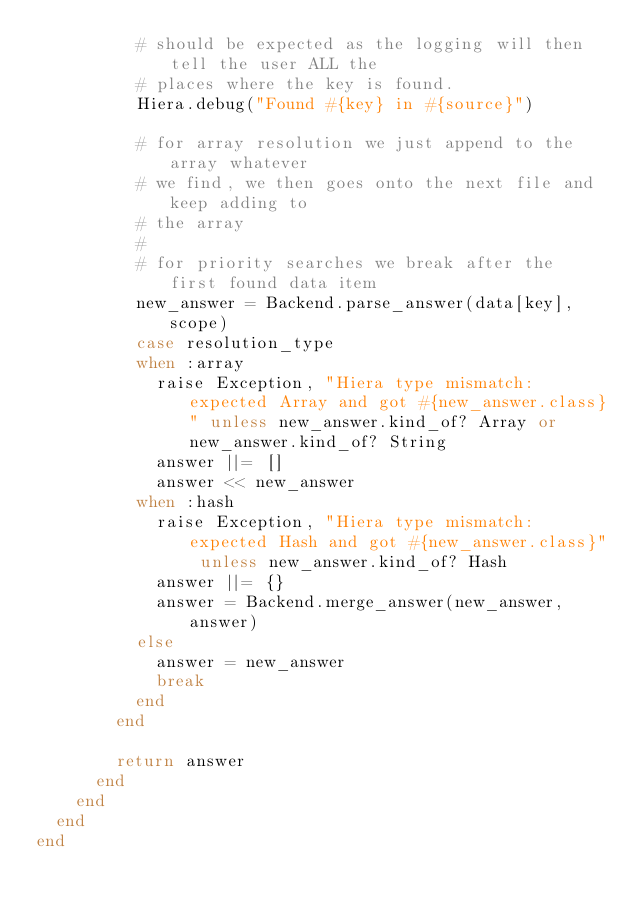<code> <loc_0><loc_0><loc_500><loc_500><_Ruby_>          # should be expected as the logging will then tell the user ALL the
          # places where the key is found.
          Hiera.debug("Found #{key} in #{source}")

          # for array resolution we just append to the array whatever
          # we find, we then goes onto the next file and keep adding to
          # the array
          #
          # for priority searches we break after the first found data item
          new_answer = Backend.parse_answer(data[key], scope)
          case resolution_type
          when :array
            raise Exception, "Hiera type mismatch: expected Array and got #{new_answer.class}" unless new_answer.kind_of? Array or new_answer.kind_of? String
            answer ||= []
            answer << new_answer
          when :hash
            raise Exception, "Hiera type mismatch: expected Hash and got #{new_answer.class}" unless new_answer.kind_of? Hash
            answer ||= {}
            answer = Backend.merge_answer(new_answer,answer)
          else
            answer = new_answer
            break
          end
        end

        return answer
      end
    end
  end
end
</code> 